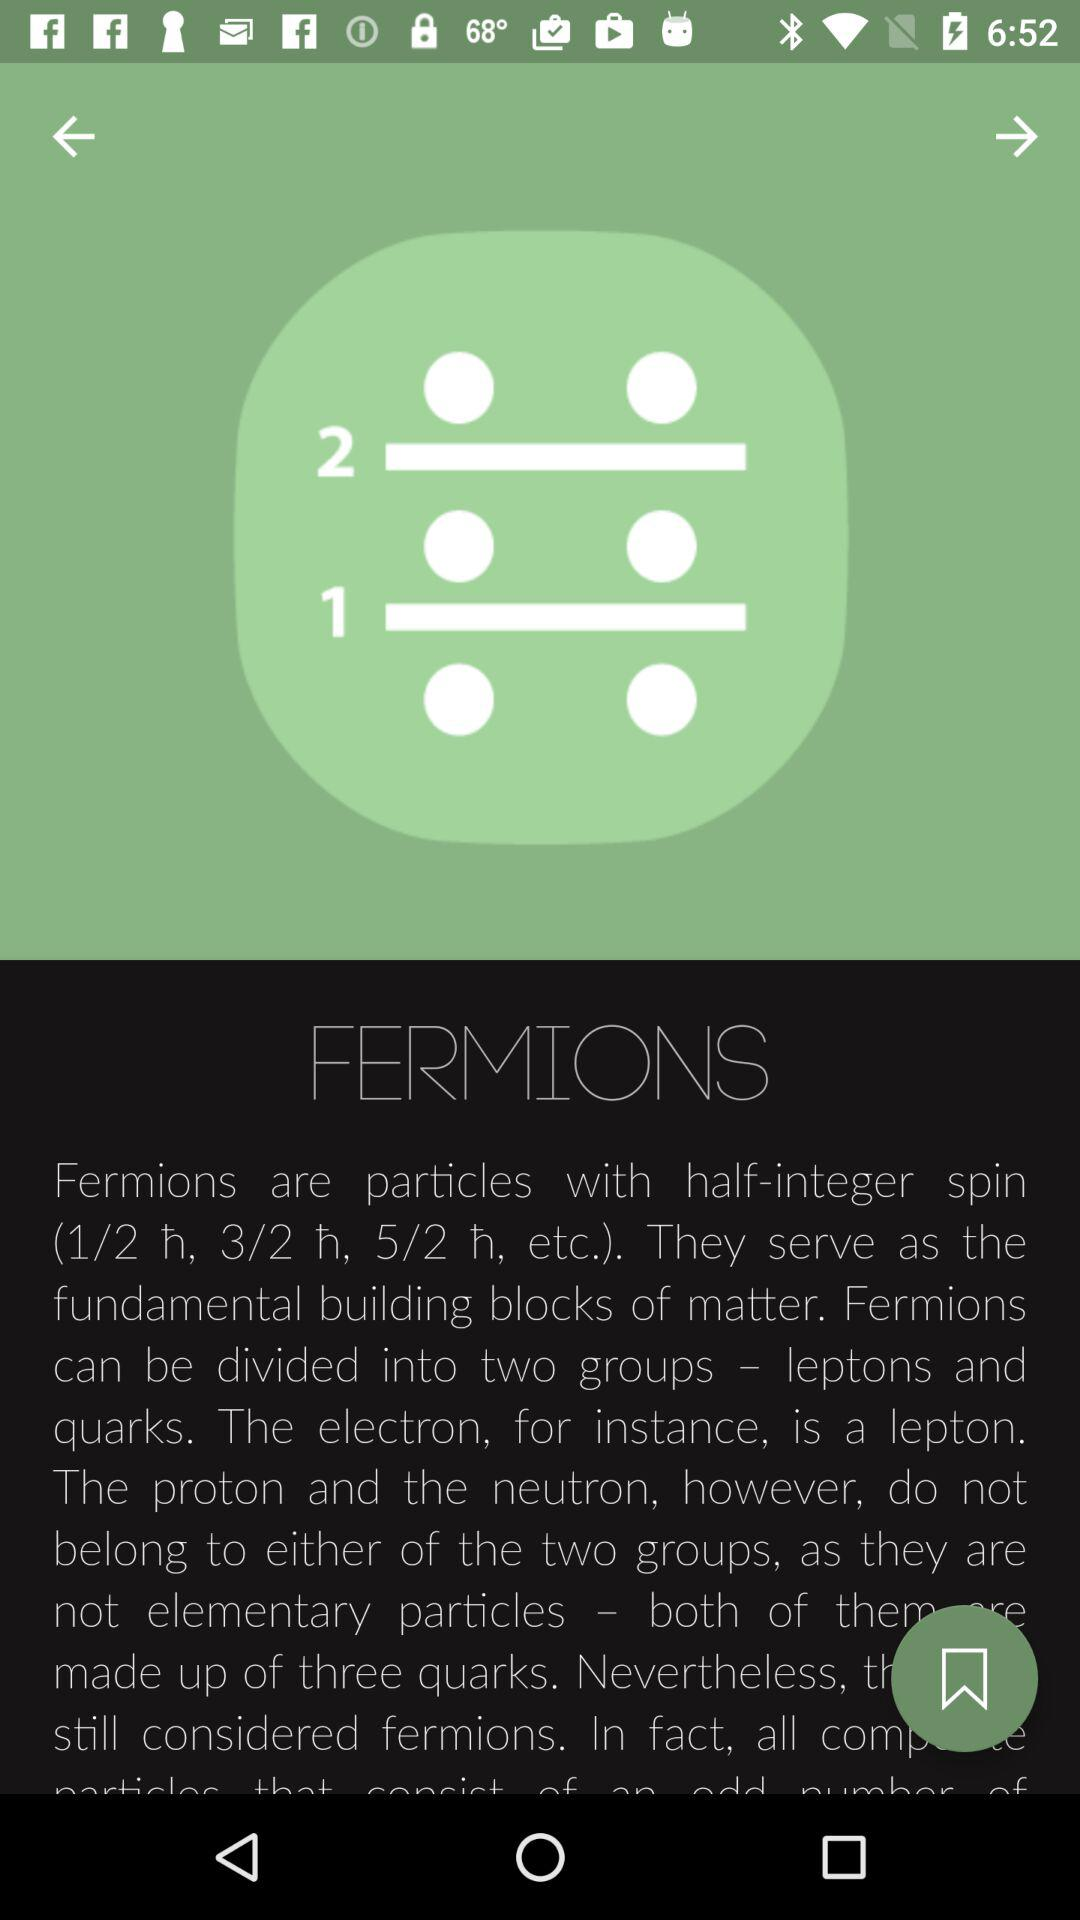What is the app name?
When the provided information is insufficient, respond with <no answer>. <no answer> 